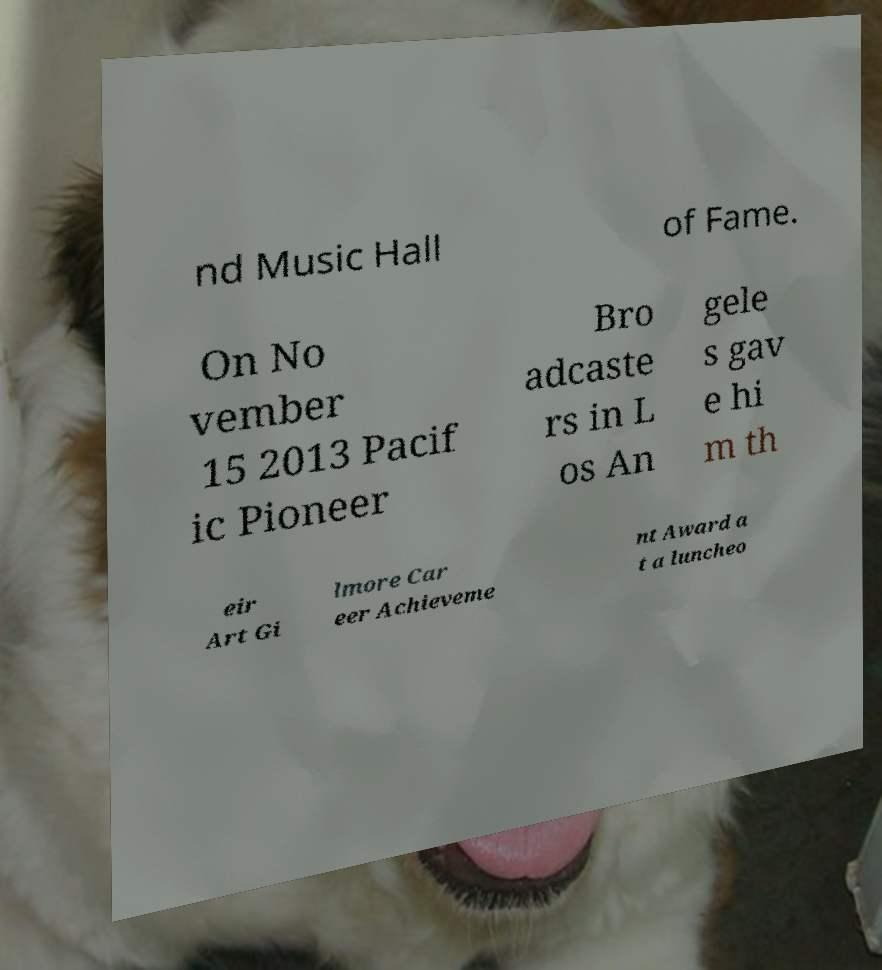What messages or text are displayed in this image? I need them in a readable, typed format. nd Music Hall of Fame. On No vember 15 2013 Pacif ic Pioneer Bro adcaste rs in L os An gele s gav e hi m th eir Art Gi lmore Car eer Achieveme nt Award a t a luncheo 